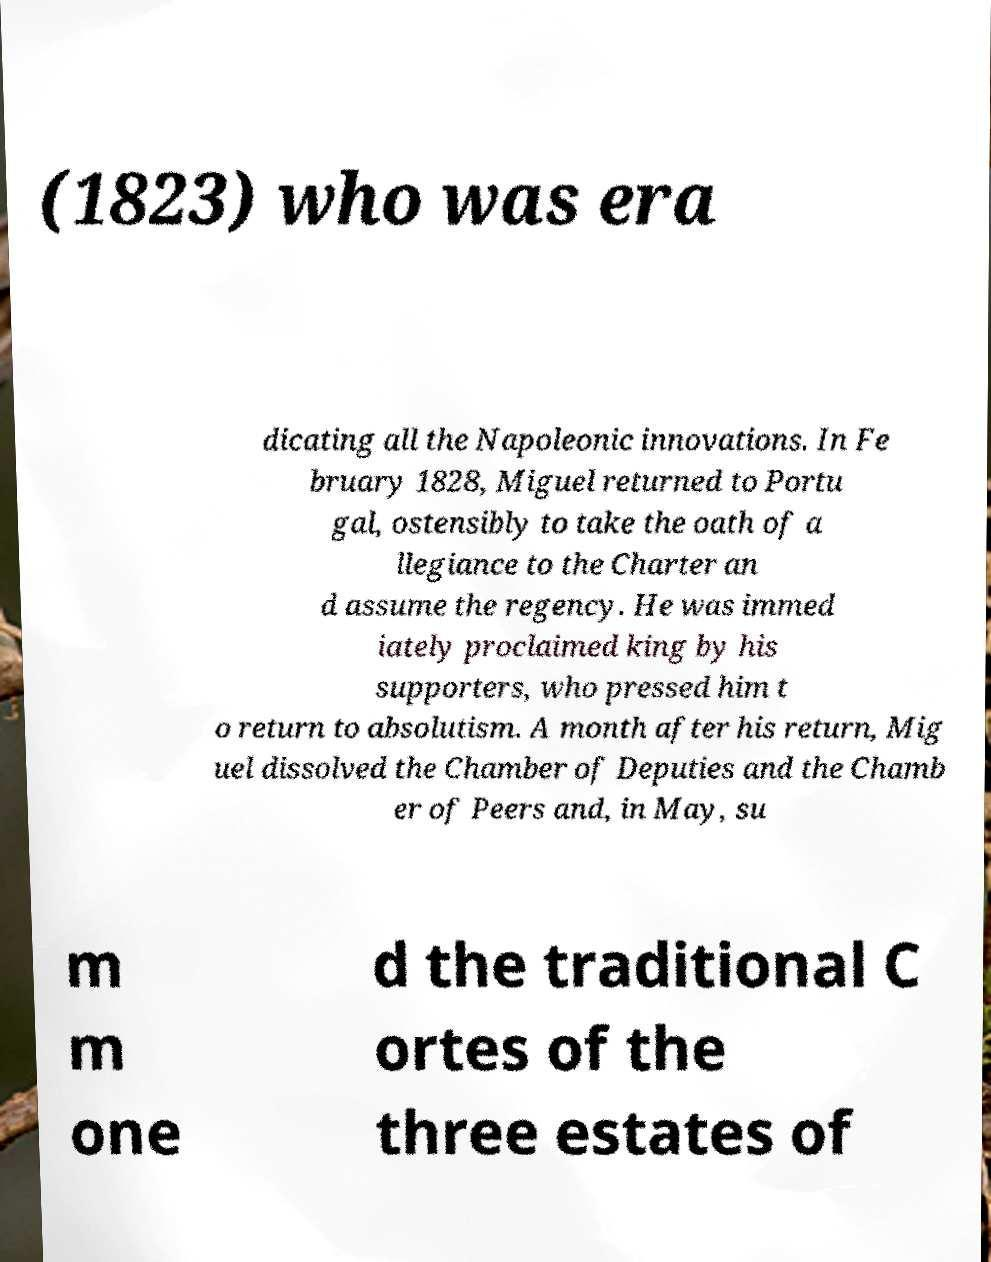Can you accurately transcribe the text from the provided image for me? (1823) who was era dicating all the Napoleonic innovations. In Fe bruary 1828, Miguel returned to Portu gal, ostensibly to take the oath of a llegiance to the Charter an d assume the regency. He was immed iately proclaimed king by his supporters, who pressed him t o return to absolutism. A month after his return, Mig uel dissolved the Chamber of Deputies and the Chamb er of Peers and, in May, su m m one d the traditional C ortes of the three estates of 